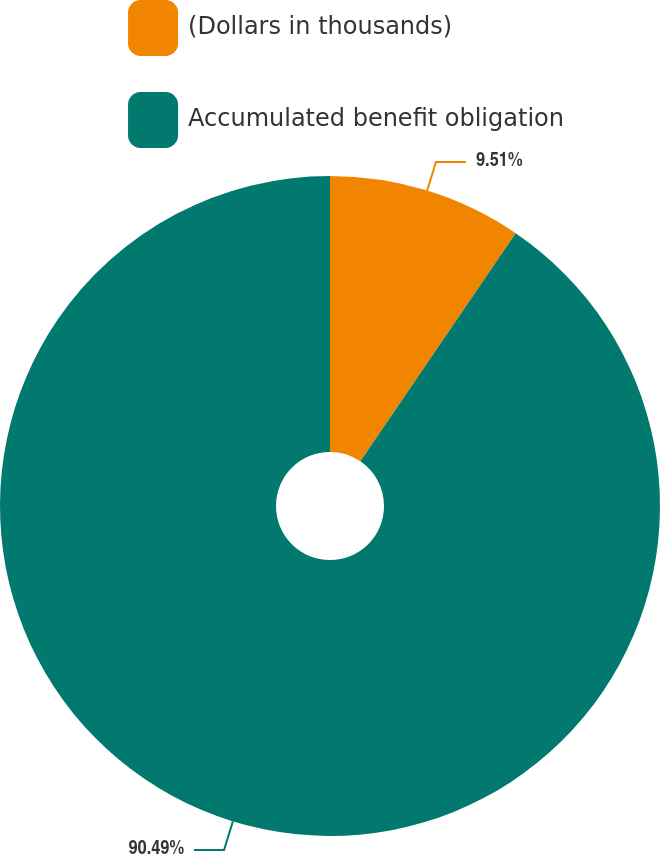Convert chart. <chart><loc_0><loc_0><loc_500><loc_500><pie_chart><fcel>(Dollars in thousands)<fcel>Accumulated benefit obligation<nl><fcel>9.51%<fcel>90.49%<nl></chart> 